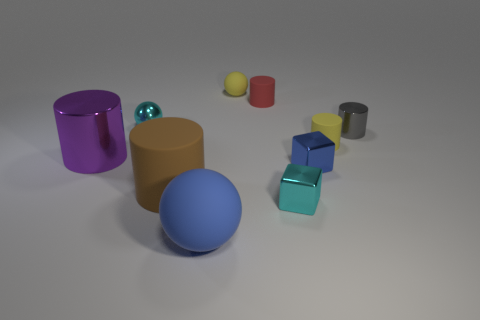Is the shape of the big thing that is behind the tiny blue metal cube the same as  the tiny blue shiny object?
Make the answer very short. No. There is a cyan metal object in front of the metal sphere; what shape is it?
Provide a short and direct response. Cube. There is a small metallic thing that is the same color as the big matte sphere; what is its shape?
Provide a short and direct response. Cube. What number of cubes have the same size as the gray cylinder?
Provide a succinct answer. 2. What color is the big rubber cylinder?
Offer a terse response. Brown. There is a small matte ball; is it the same color as the sphere that is in front of the brown thing?
Make the answer very short. No. The cyan cube that is the same material as the small cyan ball is what size?
Provide a succinct answer. Small. Is there a metal thing that has the same color as the small rubber ball?
Keep it short and to the point. No. How many objects are either cyan shiny objects in front of the large brown cylinder or tiny metal things?
Your answer should be very brief. 4. Are the big purple cylinder and the small cyan thing that is in front of the large brown matte thing made of the same material?
Offer a very short reply. Yes. 